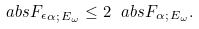Convert formula to latex. <formula><loc_0><loc_0><loc_500><loc_500>\ a b s { F _ { \epsilon } } _ { \alpha ; \, E _ { \omega } } \leq 2 \ a b s { F } _ { \alpha ; \, E _ { \omega } } .</formula> 